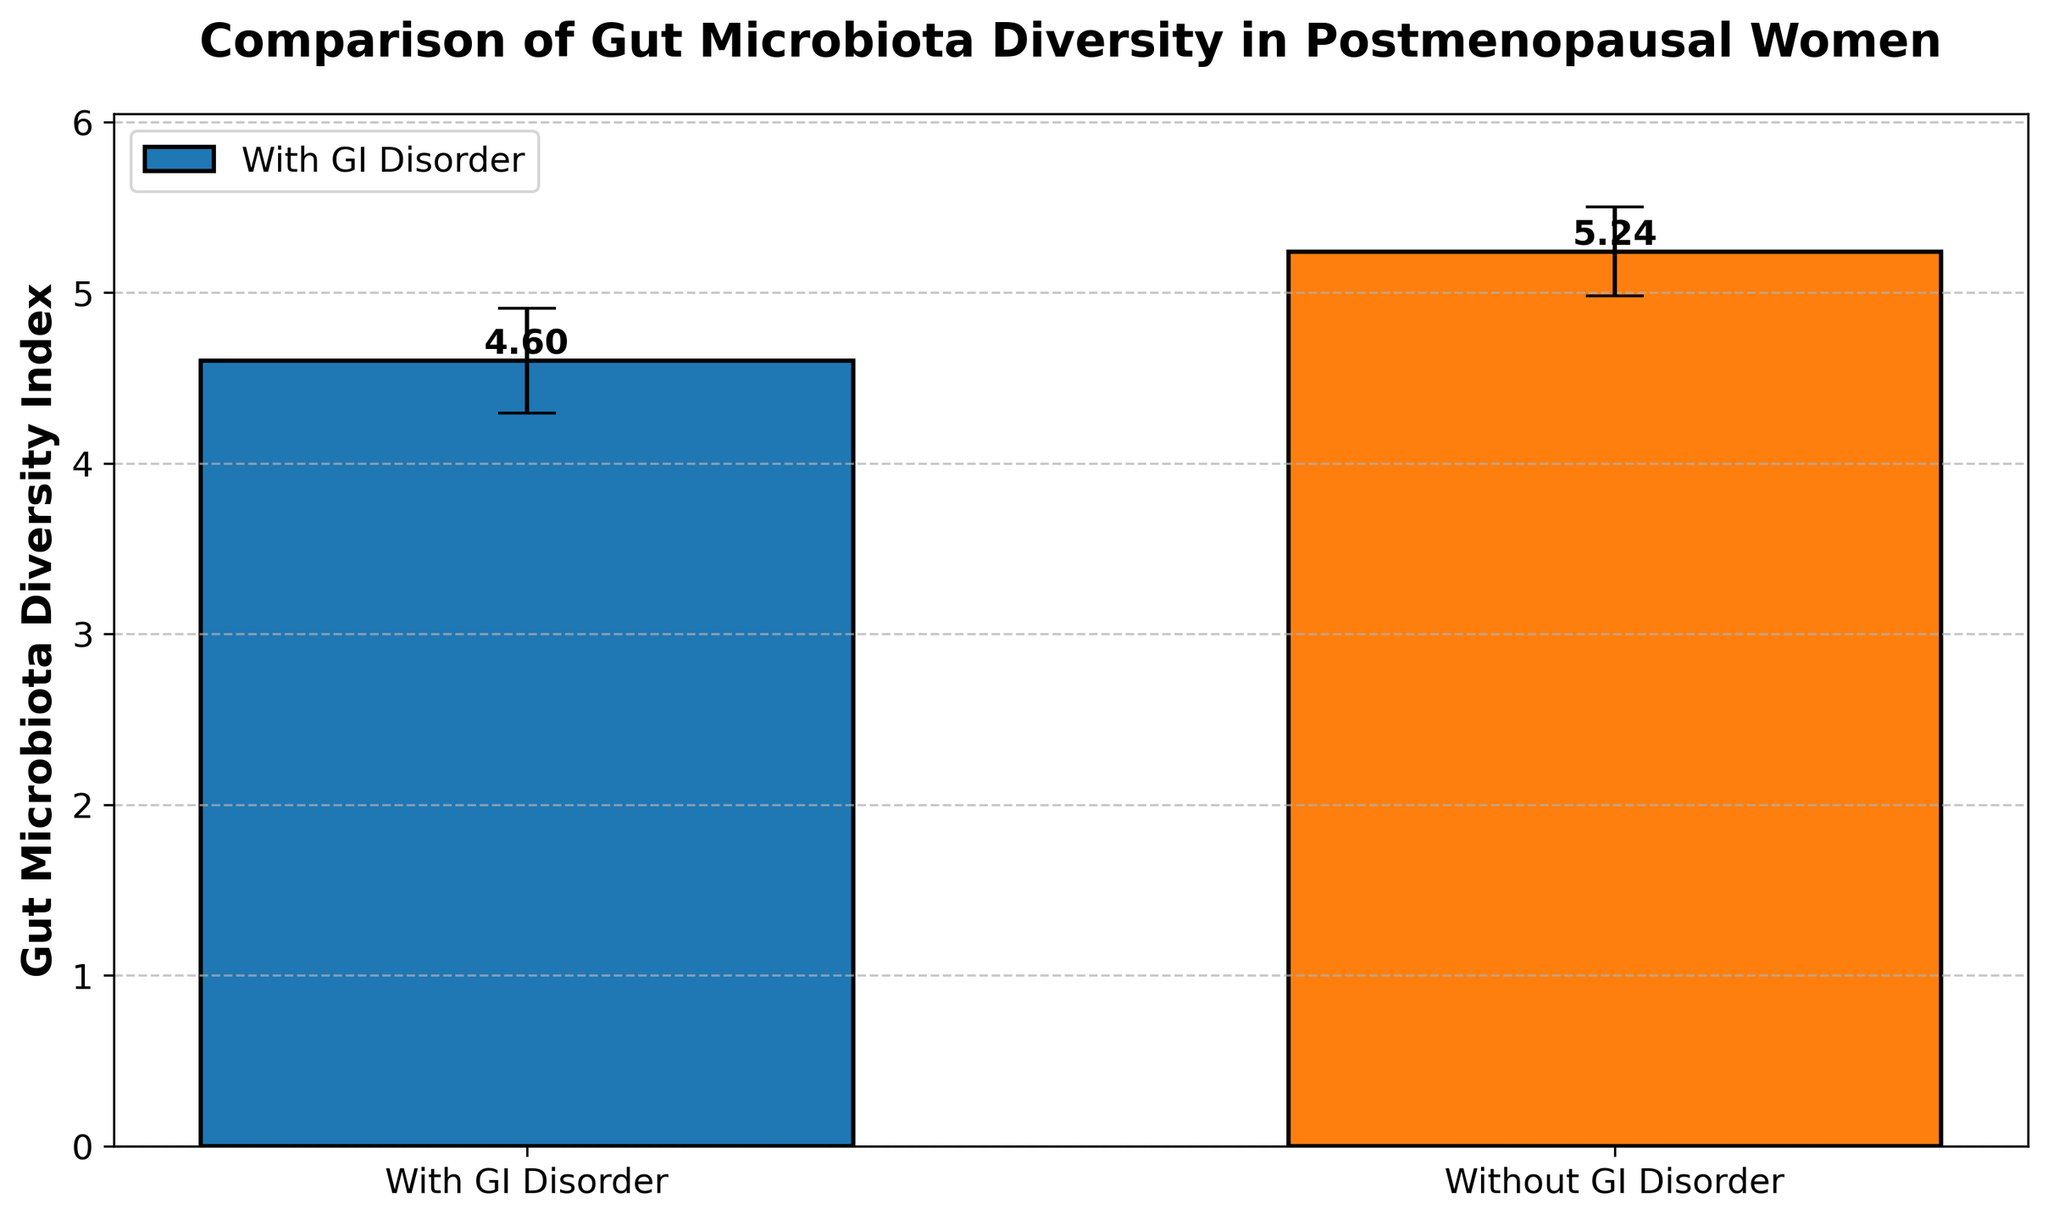What is the title of the figure? The title of the figure is located at the top and it reads "Comparison of Gut Microbiota Diversity in Postmenopausal Women".
Answer: Comparison of Gut Microbiota Diversity in Postmenopausal Women What are the two groups being compared in the figure? The two groups being compared, as indicated by the x-axis labels, are "With GI Disorder" and "Without GI Disorder".
Answer: With GI Disorder, Without GI Disorder Which group has a higher average gut microbiota diversity index? The higher average diversity index is indicated by the taller bar. The "Without GI Disorder" group has the taller bar.
Answer: Without GI Disorder What is the approximate gut microbiota diversity index for postmenopausal women without GI Disorder? The height of the bar for the "Without GI Disorder" group is about 5.2, as indicated by the value label on top of the bar.
Answer: 5.2 What is the standard deviation of the gut microbiota diversity index for postmenopausal women with GI Disorder? The error bar, which represents the standard deviation, for the "With GI Disorder" group shows the range of the error. The standard deviation is approximately 0.31, as inferred from the bar's error range.
Answer: 0.31 How does the average diversity index for women without GI Disorder compare to that of women with GI Disorder? The average diversity index for women without GI Disorder is higher compared to that for women with GI Disorder, as shown by the difference in the bar heights.
Answer: Higher What is the difference between the means of the two groups? First, note the mean values: 4.6 for "With GI Disorder" and 5.2 for "Without GI Disorder". The difference is calculated as 5.2 - 4.6 = 0.6.
Answer: 0.6 How does the standard deviation of the "Without GI Disorder" group compare to that of the "With GI Disorder" group? The mean standard deviation for "Without GI Disorder" (0.26) is slightly lower than that of "With GI Disorder" (0.31).
Answer: Slightly lower 